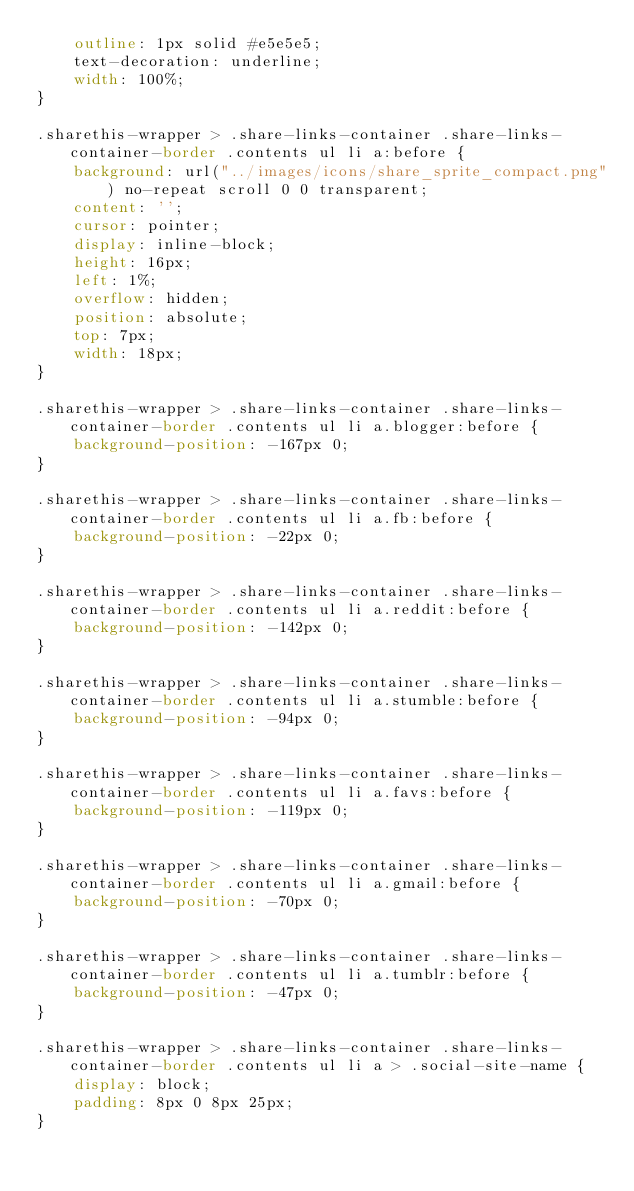Convert code to text. <code><loc_0><loc_0><loc_500><loc_500><_CSS_>    outline: 1px solid #e5e5e5;
    text-decoration: underline;
    width: 100%;
}

.sharethis-wrapper > .share-links-container .share-links-container-border .contents ul li a:before {
    background: url("../images/icons/share_sprite_compact.png") no-repeat scroll 0 0 transparent;
    content: '';
    cursor: pointer;
    display: inline-block;
    height: 16px;
    left: 1%;
    overflow: hidden;
    position: absolute;
    top: 7px;
    width: 18px;
}

.sharethis-wrapper > .share-links-container .share-links-container-border .contents ul li a.blogger:before {
    background-position: -167px 0;
}

.sharethis-wrapper > .share-links-container .share-links-container-border .contents ul li a.fb:before {
    background-position: -22px 0;
}

.sharethis-wrapper > .share-links-container .share-links-container-border .contents ul li a.reddit:before {
    background-position: -142px 0;
}

.sharethis-wrapper > .share-links-container .share-links-container-border .contents ul li a.stumble:before {
    background-position: -94px 0;
}

.sharethis-wrapper > .share-links-container .share-links-container-border .contents ul li a.favs:before {
    background-position: -119px 0;
}

.sharethis-wrapper > .share-links-container .share-links-container-border .contents ul li a.gmail:before {
    background-position: -70px 0;
}

.sharethis-wrapper > .share-links-container .share-links-container-border .contents ul li a.tumblr:before {
    background-position: -47px 0;
}

.sharethis-wrapper > .share-links-container .share-links-container-border .contents ul li a > .social-site-name {
    display: block;
    padding: 8px 0 8px 25px;
}
</code> 